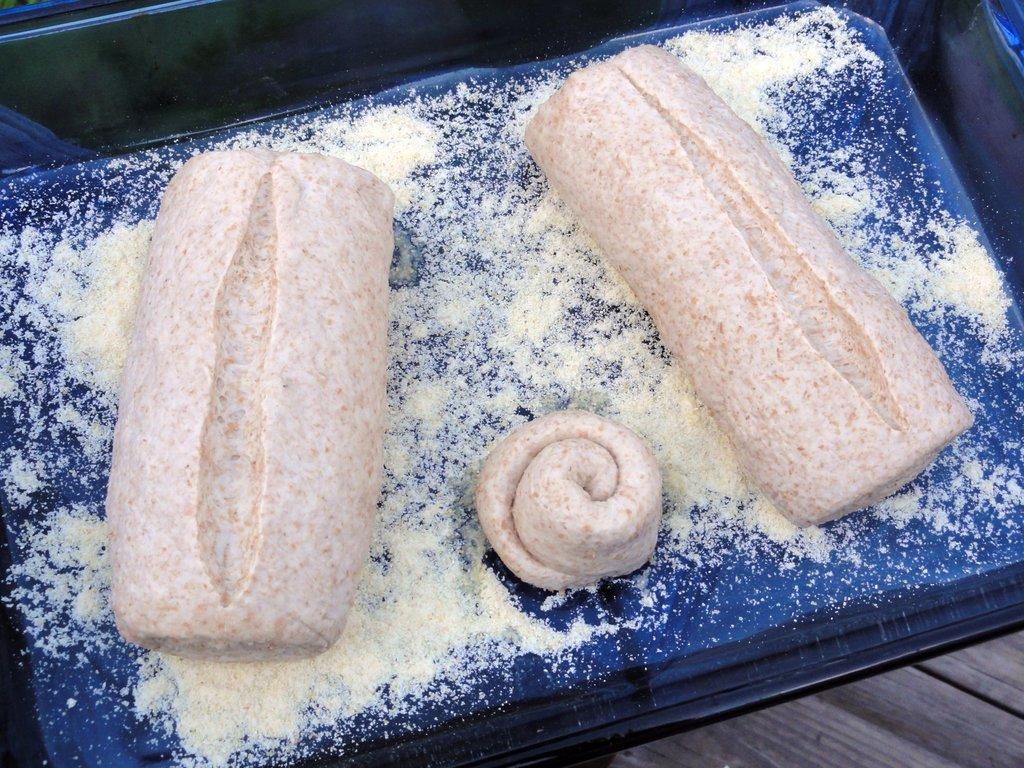Describe this image in one or two sentences. In this image we can see some food item which is placed in the black color box. 